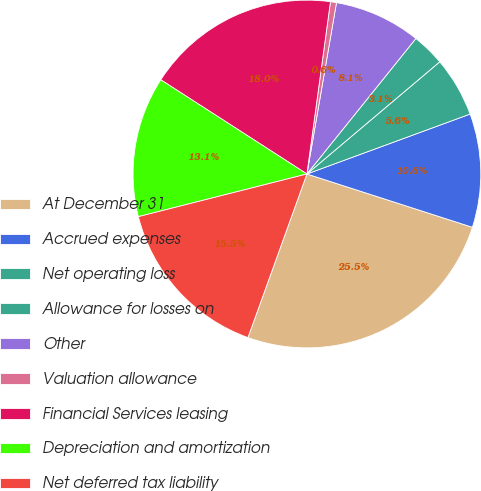Convert chart to OTSL. <chart><loc_0><loc_0><loc_500><loc_500><pie_chart><fcel>At December 31<fcel>Accrued expenses<fcel>Net operating loss<fcel>Allowance for losses on<fcel>Other<fcel>Valuation allowance<fcel>Financial Services leasing<fcel>Depreciation and amortization<fcel>Net deferred tax liability<nl><fcel>25.55%<fcel>10.56%<fcel>5.56%<fcel>3.06%<fcel>8.06%<fcel>0.56%<fcel>18.05%<fcel>13.06%<fcel>15.55%<nl></chart> 